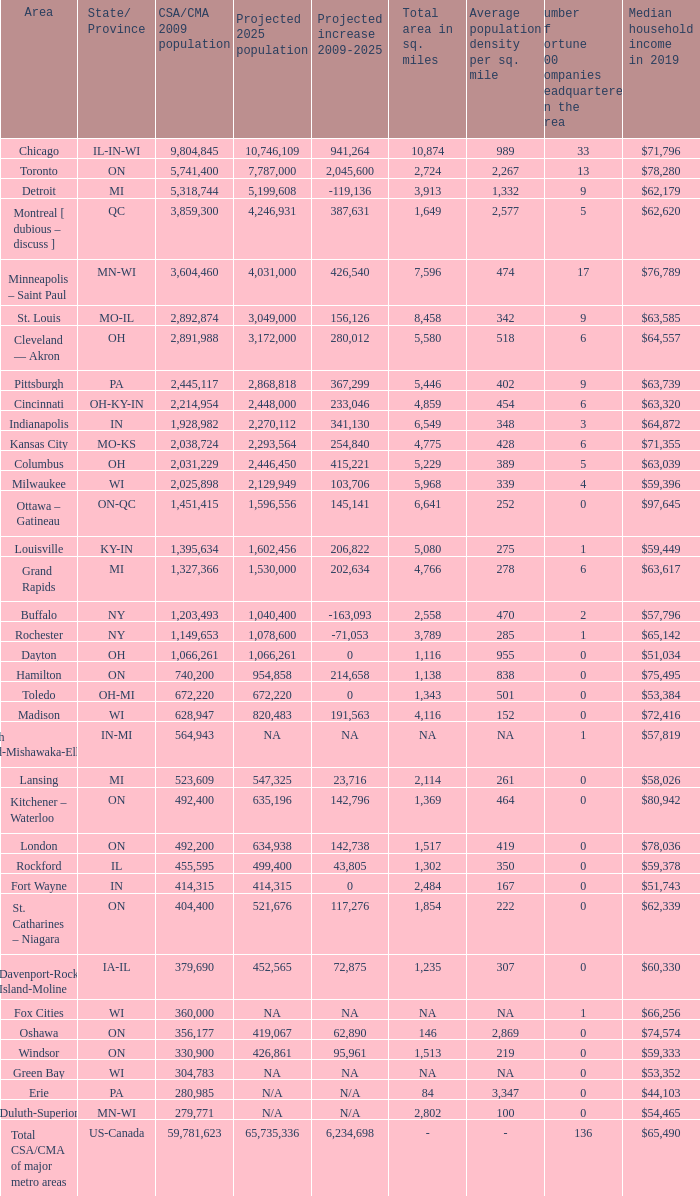What's the projected population of IN-MI? NA. 